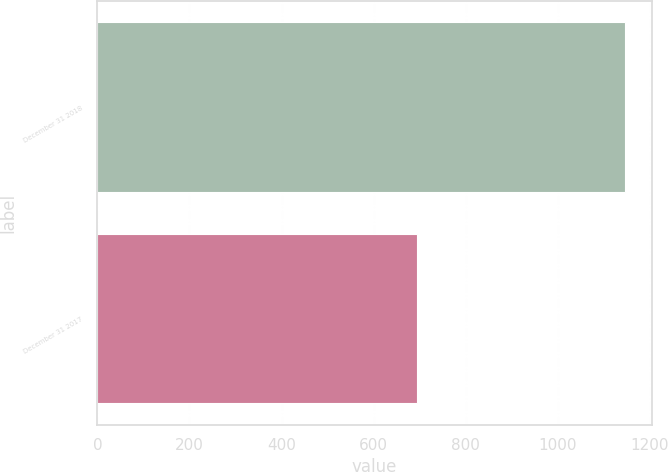Convert chart. <chart><loc_0><loc_0><loc_500><loc_500><bar_chart><fcel>December 31 2018<fcel>December 31 2017<nl><fcel>1146<fcel>695<nl></chart> 